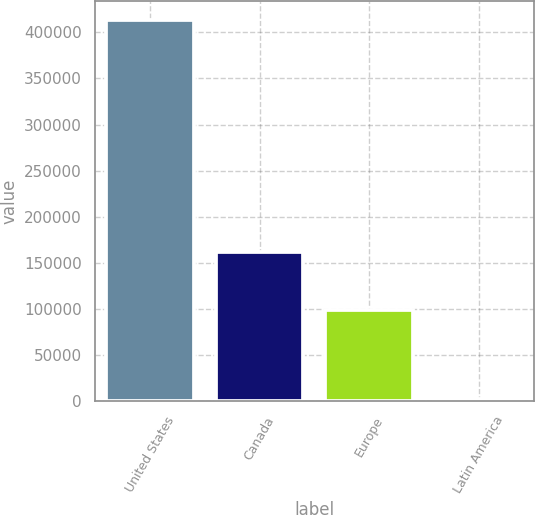Convert chart. <chart><loc_0><loc_0><loc_500><loc_500><bar_chart><fcel>United States<fcel>Canada<fcel>Europe<fcel>Latin America<nl><fcel>413278<fcel>161229<fcel>98281<fcel>2614<nl></chart> 